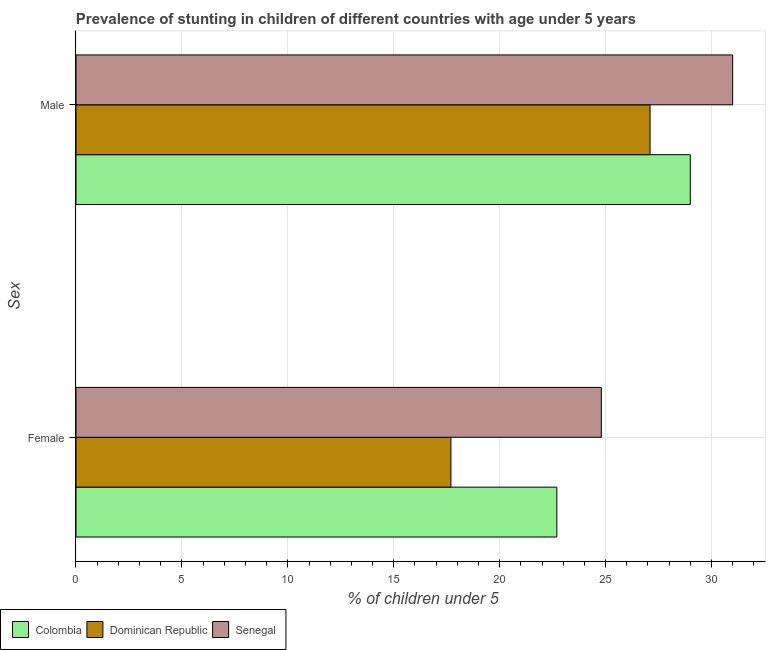How many different coloured bars are there?
Make the answer very short. 3. Are the number of bars per tick equal to the number of legend labels?
Provide a succinct answer. Yes. Are the number of bars on each tick of the Y-axis equal?
Offer a very short reply. Yes. What is the label of the 2nd group of bars from the top?
Give a very brief answer. Female. What is the percentage of stunted female children in Dominican Republic?
Your response must be concise. 17.7. Across all countries, what is the maximum percentage of stunted male children?
Offer a terse response. 31. Across all countries, what is the minimum percentage of stunted male children?
Keep it short and to the point. 27.1. In which country was the percentage of stunted male children maximum?
Offer a terse response. Senegal. In which country was the percentage of stunted female children minimum?
Give a very brief answer. Dominican Republic. What is the total percentage of stunted male children in the graph?
Provide a succinct answer. 87.1. What is the difference between the percentage of stunted female children in Senegal and that in Colombia?
Provide a short and direct response. 2.1. What is the difference between the percentage of stunted female children in Dominican Republic and the percentage of stunted male children in Senegal?
Your answer should be very brief. -13.3. What is the average percentage of stunted male children per country?
Provide a succinct answer. 29.03. What is the difference between the percentage of stunted male children and percentage of stunted female children in Colombia?
Make the answer very short. 6.3. What is the ratio of the percentage of stunted male children in Dominican Republic to that in Senegal?
Give a very brief answer. 0.87. Is the percentage of stunted male children in Dominican Republic less than that in Senegal?
Make the answer very short. Yes. In how many countries, is the percentage of stunted male children greater than the average percentage of stunted male children taken over all countries?
Give a very brief answer. 1. What does the 1st bar from the bottom in Female represents?
Offer a very short reply. Colombia. How many bars are there?
Provide a succinct answer. 6. What is the difference between two consecutive major ticks on the X-axis?
Provide a short and direct response. 5. Are the values on the major ticks of X-axis written in scientific E-notation?
Provide a succinct answer. No. Does the graph contain any zero values?
Provide a succinct answer. No. Does the graph contain grids?
Keep it short and to the point. Yes. How are the legend labels stacked?
Offer a very short reply. Horizontal. What is the title of the graph?
Give a very brief answer. Prevalence of stunting in children of different countries with age under 5 years. Does "Uruguay" appear as one of the legend labels in the graph?
Keep it short and to the point. No. What is the label or title of the X-axis?
Keep it short and to the point.  % of children under 5. What is the label or title of the Y-axis?
Give a very brief answer. Sex. What is the  % of children under 5 of Colombia in Female?
Your answer should be very brief. 22.7. What is the  % of children under 5 of Dominican Republic in Female?
Ensure brevity in your answer.  17.7. What is the  % of children under 5 of Senegal in Female?
Give a very brief answer. 24.8. What is the  % of children under 5 in Dominican Republic in Male?
Give a very brief answer. 27.1. What is the  % of children under 5 in Senegal in Male?
Provide a succinct answer. 31. Across all Sex, what is the maximum  % of children under 5 in Dominican Republic?
Provide a succinct answer. 27.1. Across all Sex, what is the maximum  % of children under 5 of Senegal?
Provide a short and direct response. 31. Across all Sex, what is the minimum  % of children under 5 of Colombia?
Ensure brevity in your answer.  22.7. Across all Sex, what is the minimum  % of children under 5 in Dominican Republic?
Give a very brief answer. 17.7. Across all Sex, what is the minimum  % of children under 5 in Senegal?
Your response must be concise. 24.8. What is the total  % of children under 5 of Colombia in the graph?
Make the answer very short. 51.7. What is the total  % of children under 5 in Dominican Republic in the graph?
Your response must be concise. 44.8. What is the total  % of children under 5 of Senegal in the graph?
Offer a terse response. 55.8. What is the difference between the  % of children under 5 of Senegal in Female and that in Male?
Your answer should be very brief. -6.2. What is the difference between the  % of children under 5 in Colombia in Female and the  % of children under 5 in Senegal in Male?
Your answer should be compact. -8.3. What is the average  % of children under 5 in Colombia per Sex?
Keep it short and to the point. 25.85. What is the average  % of children under 5 of Dominican Republic per Sex?
Your answer should be compact. 22.4. What is the average  % of children under 5 in Senegal per Sex?
Your answer should be compact. 27.9. What is the difference between the  % of children under 5 of Colombia and  % of children under 5 of Dominican Republic in Female?
Ensure brevity in your answer.  5. What is the difference between the  % of children under 5 in Colombia and  % of children under 5 in Senegal in Female?
Your answer should be very brief. -2.1. What is the difference between the  % of children under 5 of Colombia and  % of children under 5 of Dominican Republic in Male?
Offer a very short reply. 1.9. What is the ratio of the  % of children under 5 of Colombia in Female to that in Male?
Make the answer very short. 0.78. What is the ratio of the  % of children under 5 of Dominican Republic in Female to that in Male?
Provide a succinct answer. 0.65. What is the difference between the highest and the second highest  % of children under 5 of Senegal?
Keep it short and to the point. 6.2. What is the difference between the highest and the lowest  % of children under 5 in Colombia?
Offer a terse response. 6.3. What is the difference between the highest and the lowest  % of children under 5 in Senegal?
Keep it short and to the point. 6.2. 